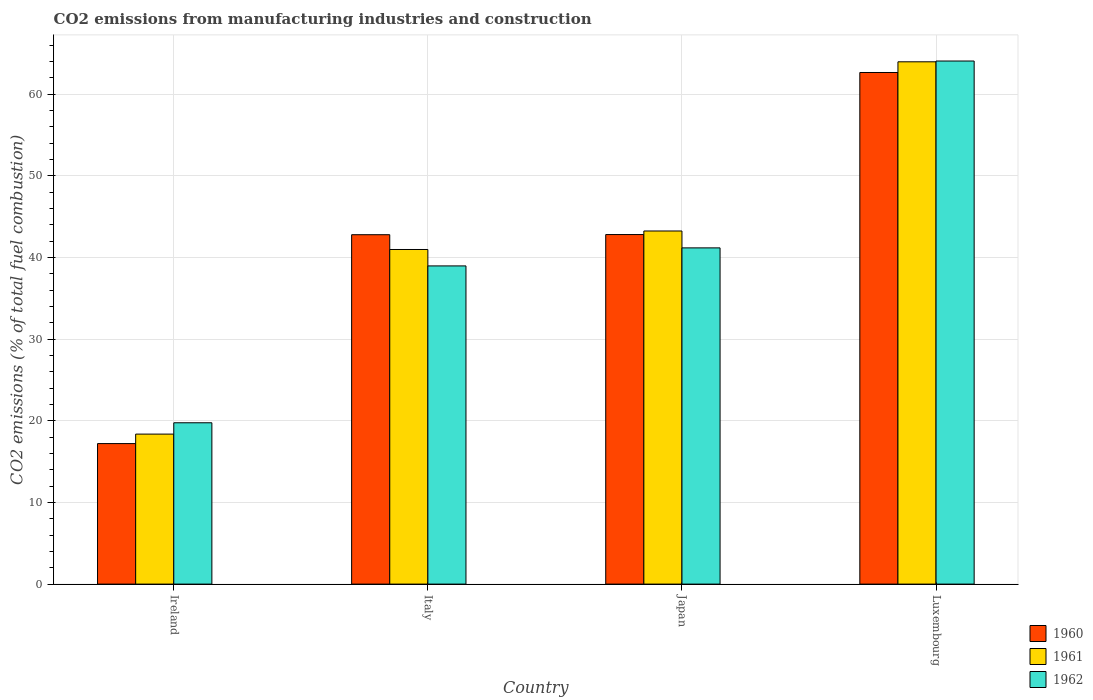Are the number of bars on each tick of the X-axis equal?
Your answer should be compact. Yes. How many bars are there on the 4th tick from the left?
Your answer should be very brief. 3. How many bars are there on the 1st tick from the right?
Provide a short and direct response. 3. What is the label of the 4th group of bars from the left?
Give a very brief answer. Luxembourg. What is the amount of CO2 emitted in 1961 in Italy?
Offer a very short reply. 40.97. Across all countries, what is the maximum amount of CO2 emitted in 1962?
Your answer should be very brief. 64.05. Across all countries, what is the minimum amount of CO2 emitted in 1962?
Provide a short and direct response. 19.75. In which country was the amount of CO2 emitted in 1962 maximum?
Your answer should be compact. Luxembourg. In which country was the amount of CO2 emitted in 1961 minimum?
Offer a terse response. Ireland. What is the total amount of CO2 emitted in 1961 in the graph?
Ensure brevity in your answer.  166.53. What is the difference between the amount of CO2 emitted in 1960 in Japan and that in Luxembourg?
Your answer should be very brief. -19.84. What is the difference between the amount of CO2 emitted in 1961 in Ireland and the amount of CO2 emitted in 1962 in Japan?
Offer a very short reply. -22.8. What is the average amount of CO2 emitted in 1961 per country?
Give a very brief answer. 41.63. What is the difference between the amount of CO2 emitted of/in 1960 and amount of CO2 emitted of/in 1961 in Japan?
Provide a short and direct response. -0.44. In how many countries, is the amount of CO2 emitted in 1960 greater than 38 %?
Provide a short and direct response. 3. What is the ratio of the amount of CO2 emitted in 1962 in Ireland to that in Luxembourg?
Offer a very short reply. 0.31. What is the difference between the highest and the second highest amount of CO2 emitted in 1961?
Make the answer very short. -2.26. What is the difference between the highest and the lowest amount of CO2 emitted in 1961?
Offer a terse response. 45.59. In how many countries, is the amount of CO2 emitted in 1960 greater than the average amount of CO2 emitted in 1960 taken over all countries?
Your response must be concise. 3. Is the sum of the amount of CO2 emitted in 1962 in Italy and Luxembourg greater than the maximum amount of CO2 emitted in 1961 across all countries?
Provide a short and direct response. Yes. What does the 2nd bar from the left in Italy represents?
Your response must be concise. 1961. What does the 3rd bar from the right in Ireland represents?
Your answer should be compact. 1960. Is it the case that in every country, the sum of the amount of CO2 emitted in 1962 and amount of CO2 emitted in 1960 is greater than the amount of CO2 emitted in 1961?
Your answer should be very brief. Yes. Are all the bars in the graph horizontal?
Give a very brief answer. No. How many countries are there in the graph?
Your response must be concise. 4. Are the values on the major ticks of Y-axis written in scientific E-notation?
Provide a succinct answer. No. Where does the legend appear in the graph?
Your answer should be compact. Bottom right. How are the legend labels stacked?
Make the answer very short. Vertical. What is the title of the graph?
Your response must be concise. CO2 emissions from manufacturing industries and construction. Does "1969" appear as one of the legend labels in the graph?
Provide a short and direct response. No. What is the label or title of the X-axis?
Your answer should be compact. Country. What is the label or title of the Y-axis?
Your answer should be compact. CO2 emissions (% of total fuel combustion). What is the CO2 emissions (% of total fuel combustion) of 1960 in Ireland?
Provide a succinct answer. 17.21. What is the CO2 emissions (% of total fuel combustion) in 1961 in Ireland?
Offer a terse response. 18.37. What is the CO2 emissions (% of total fuel combustion) in 1962 in Ireland?
Your answer should be compact. 19.75. What is the CO2 emissions (% of total fuel combustion) in 1960 in Italy?
Ensure brevity in your answer.  42.78. What is the CO2 emissions (% of total fuel combustion) of 1961 in Italy?
Provide a short and direct response. 40.97. What is the CO2 emissions (% of total fuel combustion) in 1962 in Italy?
Give a very brief answer. 38.96. What is the CO2 emissions (% of total fuel combustion) in 1960 in Japan?
Provide a short and direct response. 42.8. What is the CO2 emissions (% of total fuel combustion) of 1961 in Japan?
Keep it short and to the point. 43.24. What is the CO2 emissions (% of total fuel combustion) in 1962 in Japan?
Your answer should be compact. 41.17. What is the CO2 emissions (% of total fuel combustion) of 1960 in Luxembourg?
Offer a terse response. 62.65. What is the CO2 emissions (% of total fuel combustion) in 1961 in Luxembourg?
Offer a terse response. 63.95. What is the CO2 emissions (% of total fuel combustion) of 1962 in Luxembourg?
Offer a terse response. 64.05. Across all countries, what is the maximum CO2 emissions (% of total fuel combustion) of 1960?
Provide a succinct answer. 62.65. Across all countries, what is the maximum CO2 emissions (% of total fuel combustion) of 1961?
Provide a succinct answer. 63.95. Across all countries, what is the maximum CO2 emissions (% of total fuel combustion) of 1962?
Your answer should be compact. 64.05. Across all countries, what is the minimum CO2 emissions (% of total fuel combustion) in 1960?
Ensure brevity in your answer.  17.21. Across all countries, what is the minimum CO2 emissions (% of total fuel combustion) of 1961?
Make the answer very short. 18.37. Across all countries, what is the minimum CO2 emissions (% of total fuel combustion) of 1962?
Provide a succinct answer. 19.75. What is the total CO2 emissions (% of total fuel combustion) in 1960 in the graph?
Give a very brief answer. 165.44. What is the total CO2 emissions (% of total fuel combustion) in 1961 in the graph?
Ensure brevity in your answer.  166.53. What is the total CO2 emissions (% of total fuel combustion) in 1962 in the graph?
Your answer should be very brief. 163.93. What is the difference between the CO2 emissions (% of total fuel combustion) of 1960 in Ireland and that in Italy?
Provide a short and direct response. -25.57. What is the difference between the CO2 emissions (% of total fuel combustion) in 1961 in Ireland and that in Italy?
Ensure brevity in your answer.  -22.61. What is the difference between the CO2 emissions (% of total fuel combustion) in 1962 in Ireland and that in Italy?
Give a very brief answer. -19.21. What is the difference between the CO2 emissions (% of total fuel combustion) in 1960 in Ireland and that in Japan?
Offer a terse response. -25.6. What is the difference between the CO2 emissions (% of total fuel combustion) in 1961 in Ireland and that in Japan?
Give a very brief answer. -24.87. What is the difference between the CO2 emissions (% of total fuel combustion) of 1962 in Ireland and that in Japan?
Your answer should be very brief. -21.42. What is the difference between the CO2 emissions (% of total fuel combustion) in 1960 in Ireland and that in Luxembourg?
Your answer should be compact. -45.44. What is the difference between the CO2 emissions (% of total fuel combustion) of 1961 in Ireland and that in Luxembourg?
Your answer should be very brief. -45.59. What is the difference between the CO2 emissions (% of total fuel combustion) in 1962 in Ireland and that in Luxembourg?
Give a very brief answer. -44.3. What is the difference between the CO2 emissions (% of total fuel combustion) in 1960 in Italy and that in Japan?
Your response must be concise. -0.02. What is the difference between the CO2 emissions (% of total fuel combustion) in 1961 in Italy and that in Japan?
Your response must be concise. -2.26. What is the difference between the CO2 emissions (% of total fuel combustion) in 1962 in Italy and that in Japan?
Ensure brevity in your answer.  -2.21. What is the difference between the CO2 emissions (% of total fuel combustion) of 1960 in Italy and that in Luxembourg?
Keep it short and to the point. -19.86. What is the difference between the CO2 emissions (% of total fuel combustion) of 1961 in Italy and that in Luxembourg?
Give a very brief answer. -22.98. What is the difference between the CO2 emissions (% of total fuel combustion) of 1962 in Italy and that in Luxembourg?
Provide a succinct answer. -25.09. What is the difference between the CO2 emissions (% of total fuel combustion) of 1960 in Japan and that in Luxembourg?
Your answer should be very brief. -19.84. What is the difference between the CO2 emissions (% of total fuel combustion) in 1961 in Japan and that in Luxembourg?
Offer a very short reply. -20.72. What is the difference between the CO2 emissions (% of total fuel combustion) in 1962 in Japan and that in Luxembourg?
Your response must be concise. -22.88. What is the difference between the CO2 emissions (% of total fuel combustion) of 1960 in Ireland and the CO2 emissions (% of total fuel combustion) of 1961 in Italy?
Make the answer very short. -23.77. What is the difference between the CO2 emissions (% of total fuel combustion) of 1960 in Ireland and the CO2 emissions (% of total fuel combustion) of 1962 in Italy?
Your answer should be compact. -21.75. What is the difference between the CO2 emissions (% of total fuel combustion) in 1961 in Ireland and the CO2 emissions (% of total fuel combustion) in 1962 in Italy?
Provide a succinct answer. -20.59. What is the difference between the CO2 emissions (% of total fuel combustion) of 1960 in Ireland and the CO2 emissions (% of total fuel combustion) of 1961 in Japan?
Offer a terse response. -26.03. What is the difference between the CO2 emissions (% of total fuel combustion) in 1960 in Ireland and the CO2 emissions (% of total fuel combustion) in 1962 in Japan?
Provide a short and direct response. -23.96. What is the difference between the CO2 emissions (% of total fuel combustion) of 1961 in Ireland and the CO2 emissions (% of total fuel combustion) of 1962 in Japan?
Your response must be concise. -22.8. What is the difference between the CO2 emissions (% of total fuel combustion) of 1960 in Ireland and the CO2 emissions (% of total fuel combustion) of 1961 in Luxembourg?
Ensure brevity in your answer.  -46.75. What is the difference between the CO2 emissions (% of total fuel combustion) in 1960 in Ireland and the CO2 emissions (% of total fuel combustion) in 1962 in Luxembourg?
Ensure brevity in your answer.  -46.84. What is the difference between the CO2 emissions (% of total fuel combustion) of 1961 in Ireland and the CO2 emissions (% of total fuel combustion) of 1962 in Luxembourg?
Your answer should be compact. -45.68. What is the difference between the CO2 emissions (% of total fuel combustion) of 1960 in Italy and the CO2 emissions (% of total fuel combustion) of 1961 in Japan?
Your response must be concise. -0.46. What is the difference between the CO2 emissions (% of total fuel combustion) in 1960 in Italy and the CO2 emissions (% of total fuel combustion) in 1962 in Japan?
Your response must be concise. 1.61. What is the difference between the CO2 emissions (% of total fuel combustion) of 1961 in Italy and the CO2 emissions (% of total fuel combustion) of 1962 in Japan?
Ensure brevity in your answer.  -0.2. What is the difference between the CO2 emissions (% of total fuel combustion) in 1960 in Italy and the CO2 emissions (% of total fuel combustion) in 1961 in Luxembourg?
Offer a very short reply. -21.17. What is the difference between the CO2 emissions (% of total fuel combustion) of 1960 in Italy and the CO2 emissions (% of total fuel combustion) of 1962 in Luxembourg?
Offer a very short reply. -21.27. What is the difference between the CO2 emissions (% of total fuel combustion) of 1961 in Italy and the CO2 emissions (% of total fuel combustion) of 1962 in Luxembourg?
Offer a terse response. -23.08. What is the difference between the CO2 emissions (% of total fuel combustion) of 1960 in Japan and the CO2 emissions (% of total fuel combustion) of 1961 in Luxembourg?
Your response must be concise. -21.15. What is the difference between the CO2 emissions (% of total fuel combustion) in 1960 in Japan and the CO2 emissions (% of total fuel combustion) in 1962 in Luxembourg?
Keep it short and to the point. -21.25. What is the difference between the CO2 emissions (% of total fuel combustion) of 1961 in Japan and the CO2 emissions (% of total fuel combustion) of 1962 in Luxembourg?
Give a very brief answer. -20.81. What is the average CO2 emissions (% of total fuel combustion) of 1960 per country?
Provide a short and direct response. 41.36. What is the average CO2 emissions (% of total fuel combustion) in 1961 per country?
Your answer should be compact. 41.63. What is the average CO2 emissions (% of total fuel combustion) in 1962 per country?
Make the answer very short. 40.98. What is the difference between the CO2 emissions (% of total fuel combustion) of 1960 and CO2 emissions (% of total fuel combustion) of 1961 in Ireland?
Provide a short and direct response. -1.16. What is the difference between the CO2 emissions (% of total fuel combustion) in 1960 and CO2 emissions (% of total fuel combustion) in 1962 in Ireland?
Provide a short and direct response. -2.55. What is the difference between the CO2 emissions (% of total fuel combustion) in 1961 and CO2 emissions (% of total fuel combustion) in 1962 in Ireland?
Ensure brevity in your answer.  -1.39. What is the difference between the CO2 emissions (% of total fuel combustion) in 1960 and CO2 emissions (% of total fuel combustion) in 1961 in Italy?
Provide a short and direct response. 1.81. What is the difference between the CO2 emissions (% of total fuel combustion) in 1960 and CO2 emissions (% of total fuel combustion) in 1962 in Italy?
Ensure brevity in your answer.  3.82. What is the difference between the CO2 emissions (% of total fuel combustion) of 1961 and CO2 emissions (% of total fuel combustion) of 1962 in Italy?
Give a very brief answer. 2.01. What is the difference between the CO2 emissions (% of total fuel combustion) of 1960 and CO2 emissions (% of total fuel combustion) of 1961 in Japan?
Ensure brevity in your answer.  -0.44. What is the difference between the CO2 emissions (% of total fuel combustion) in 1960 and CO2 emissions (% of total fuel combustion) in 1962 in Japan?
Ensure brevity in your answer.  1.63. What is the difference between the CO2 emissions (% of total fuel combustion) of 1961 and CO2 emissions (% of total fuel combustion) of 1962 in Japan?
Make the answer very short. 2.07. What is the difference between the CO2 emissions (% of total fuel combustion) in 1960 and CO2 emissions (% of total fuel combustion) in 1961 in Luxembourg?
Make the answer very short. -1.31. What is the difference between the CO2 emissions (% of total fuel combustion) in 1960 and CO2 emissions (% of total fuel combustion) in 1962 in Luxembourg?
Make the answer very short. -1.4. What is the difference between the CO2 emissions (% of total fuel combustion) in 1961 and CO2 emissions (% of total fuel combustion) in 1962 in Luxembourg?
Keep it short and to the point. -0.1. What is the ratio of the CO2 emissions (% of total fuel combustion) of 1960 in Ireland to that in Italy?
Provide a short and direct response. 0.4. What is the ratio of the CO2 emissions (% of total fuel combustion) in 1961 in Ireland to that in Italy?
Make the answer very short. 0.45. What is the ratio of the CO2 emissions (% of total fuel combustion) in 1962 in Ireland to that in Italy?
Provide a succinct answer. 0.51. What is the ratio of the CO2 emissions (% of total fuel combustion) of 1960 in Ireland to that in Japan?
Make the answer very short. 0.4. What is the ratio of the CO2 emissions (% of total fuel combustion) in 1961 in Ireland to that in Japan?
Your answer should be very brief. 0.42. What is the ratio of the CO2 emissions (% of total fuel combustion) in 1962 in Ireland to that in Japan?
Make the answer very short. 0.48. What is the ratio of the CO2 emissions (% of total fuel combustion) in 1960 in Ireland to that in Luxembourg?
Give a very brief answer. 0.27. What is the ratio of the CO2 emissions (% of total fuel combustion) in 1961 in Ireland to that in Luxembourg?
Give a very brief answer. 0.29. What is the ratio of the CO2 emissions (% of total fuel combustion) of 1962 in Ireland to that in Luxembourg?
Make the answer very short. 0.31. What is the ratio of the CO2 emissions (% of total fuel combustion) in 1960 in Italy to that in Japan?
Your response must be concise. 1. What is the ratio of the CO2 emissions (% of total fuel combustion) of 1961 in Italy to that in Japan?
Provide a short and direct response. 0.95. What is the ratio of the CO2 emissions (% of total fuel combustion) in 1962 in Italy to that in Japan?
Offer a very short reply. 0.95. What is the ratio of the CO2 emissions (% of total fuel combustion) in 1960 in Italy to that in Luxembourg?
Ensure brevity in your answer.  0.68. What is the ratio of the CO2 emissions (% of total fuel combustion) of 1961 in Italy to that in Luxembourg?
Your answer should be compact. 0.64. What is the ratio of the CO2 emissions (% of total fuel combustion) in 1962 in Italy to that in Luxembourg?
Offer a very short reply. 0.61. What is the ratio of the CO2 emissions (% of total fuel combustion) of 1960 in Japan to that in Luxembourg?
Offer a terse response. 0.68. What is the ratio of the CO2 emissions (% of total fuel combustion) of 1961 in Japan to that in Luxembourg?
Make the answer very short. 0.68. What is the ratio of the CO2 emissions (% of total fuel combustion) of 1962 in Japan to that in Luxembourg?
Provide a succinct answer. 0.64. What is the difference between the highest and the second highest CO2 emissions (% of total fuel combustion) of 1960?
Provide a short and direct response. 19.84. What is the difference between the highest and the second highest CO2 emissions (% of total fuel combustion) in 1961?
Offer a very short reply. 20.72. What is the difference between the highest and the second highest CO2 emissions (% of total fuel combustion) in 1962?
Ensure brevity in your answer.  22.88. What is the difference between the highest and the lowest CO2 emissions (% of total fuel combustion) of 1960?
Offer a very short reply. 45.44. What is the difference between the highest and the lowest CO2 emissions (% of total fuel combustion) in 1961?
Keep it short and to the point. 45.59. What is the difference between the highest and the lowest CO2 emissions (% of total fuel combustion) in 1962?
Your answer should be very brief. 44.3. 